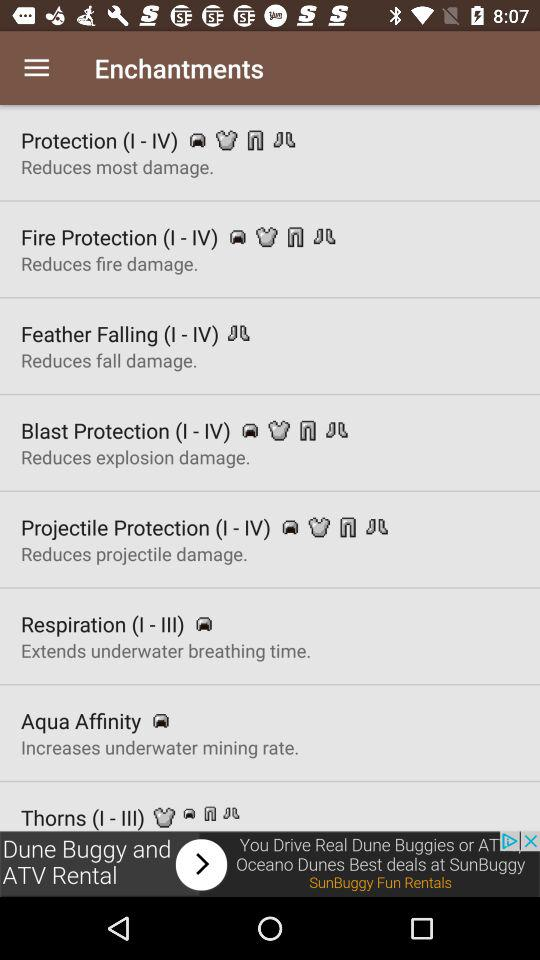How many protection enchantments are there?
Answer the question using a single word or phrase. 4 